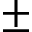Convert formula to latex. <formula><loc_0><loc_0><loc_500><loc_500>\pm</formula> 